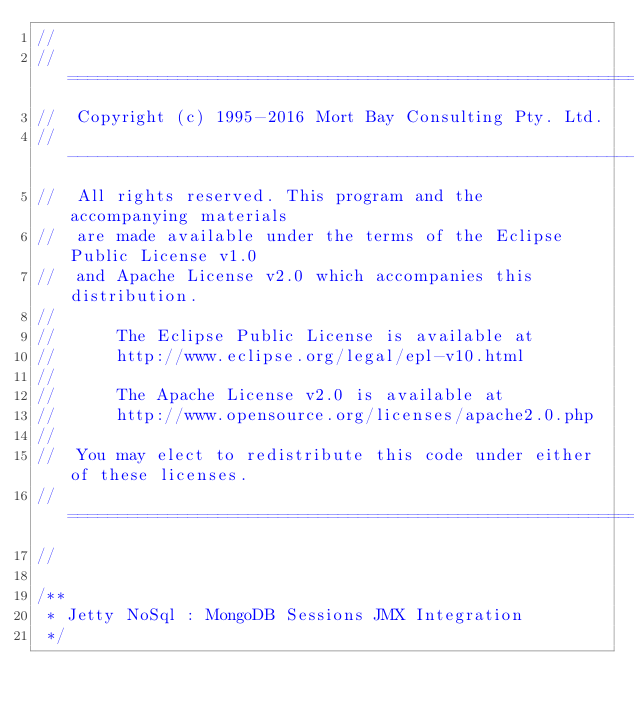Convert code to text. <code><loc_0><loc_0><loc_500><loc_500><_Java_>//
//  ========================================================================
//  Copyright (c) 1995-2016 Mort Bay Consulting Pty. Ltd.
//  ------------------------------------------------------------------------
//  All rights reserved. This program and the accompanying materials
//  are made available under the terms of the Eclipse Public License v1.0
//  and Apache License v2.0 which accompanies this distribution.
//
//      The Eclipse Public License is available at
//      http://www.eclipse.org/legal/epl-v10.html
//
//      The Apache License v2.0 is available at
//      http://www.opensource.org/licenses/apache2.0.php
//
//  You may elect to redistribute this code under either of these licenses.
//  ========================================================================
//

/**
 * Jetty NoSql : MongoDB Sessions JMX Integration
 */</code> 